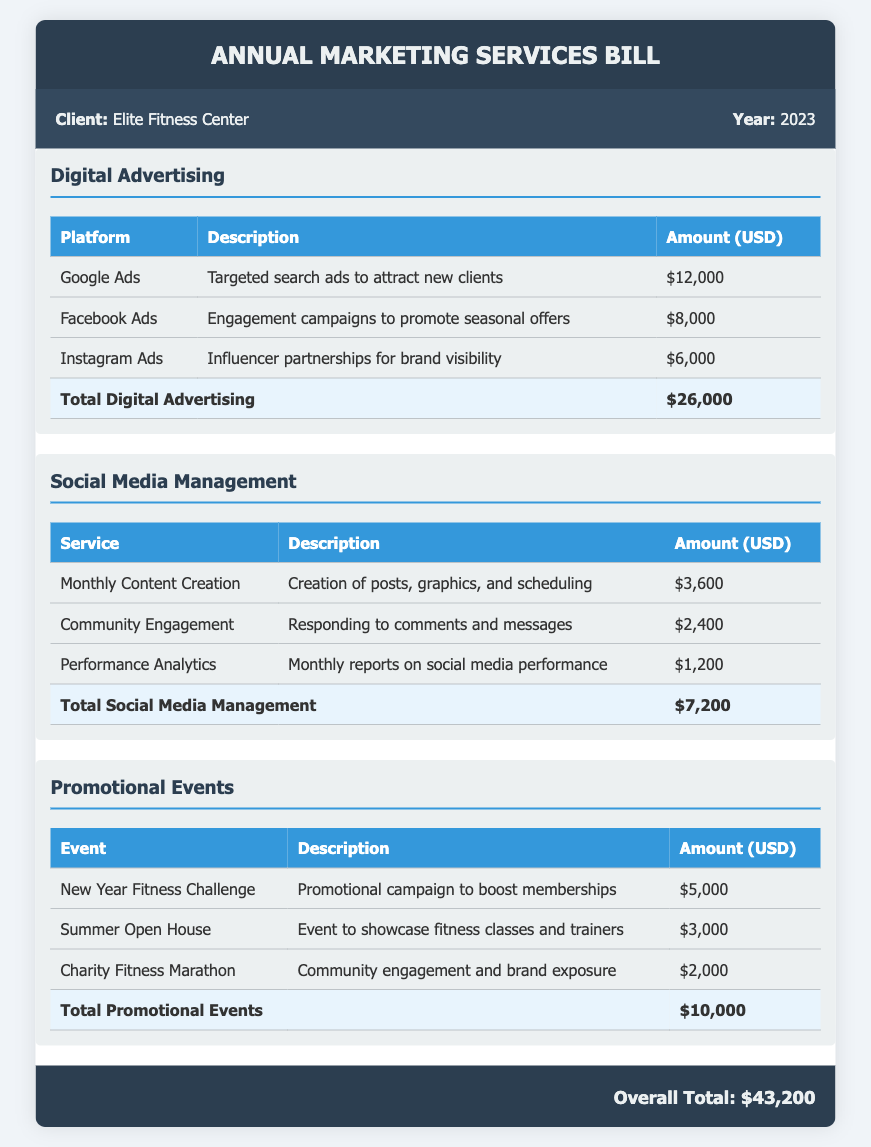What is the total amount for Digital Advertising? The total amount for Digital Advertising is listed at the bottom of the related section, which is $26,000.
Answer: $26,000 How much is spent on Social Media Management services? The total amount for Social Media Management is shown at the end of that section, amounting to $7,200.
Answer: $7,200 What is the name of the fitness challenge event? The event named in the Promotional Events section is the "New Year Fitness Challenge" listed as the first event.
Answer: New Year Fitness Challenge What is the total cost of Promotional Events? The total cost of Promotional Events is shown in that section, specifically stated as $10,000.
Answer: $10,000 Which platform has the highest advertising expense? Reviewing the Digital Advertising section, Google Ads has the highest expense of $12,000.
Answer: Google Ads How much was allocated for community engagement in Social Media Management? The description for Community Engagement indicates the allocated amount is $2,400.
Answer: $2,400 What is the overall total amount of the bill? The overall total amount is prominently displayed at the bottom of the document, totaling $43,200.
Answer: $43,200 Which social media service includes performance reporting? The service that includes performance reporting is listed as "Performance Analytics" in the Social Media Management section.
Answer: Performance Analytics What event focuses on brand exposure in the community? The event aimed at community engagement and brand exposure is the "Charity Fitness Marathon."
Answer: Charity Fitness Marathon 